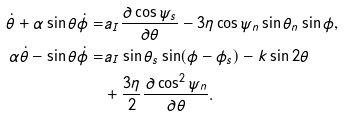<formula> <loc_0><loc_0><loc_500><loc_500>\dot { \theta } + \alpha \sin \theta \dot { \phi } = & a _ { I } \frac { \partial \cos \psi _ { s } } { \partial \theta } - 3 \eta \cos \psi _ { n } \sin \theta _ { n } \sin \phi , \\ \alpha \dot { \theta } - \sin \theta \dot { \phi } = & a _ { I } \sin \theta _ { s } \sin ( \phi - \phi _ { s } ) - k \sin 2 \theta \\ & + \frac { 3 \eta } { 2 } \frac { \partial \cos ^ { 2 } \psi _ { n } } { \partial \theta } .</formula> 